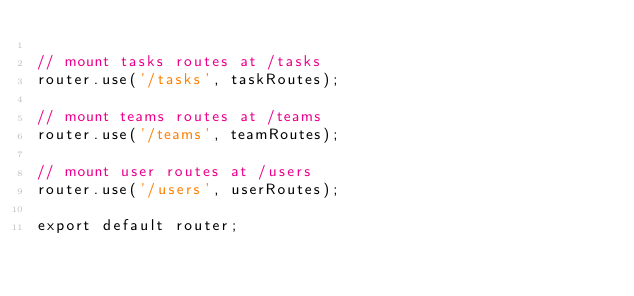<code> <loc_0><loc_0><loc_500><loc_500><_JavaScript_>
// mount tasks routes at /tasks
router.use('/tasks', taskRoutes);

// mount teams routes at /teams
router.use('/teams', teamRoutes);

// mount user routes at /users
router.use('/users', userRoutes);

export default router;
</code> 